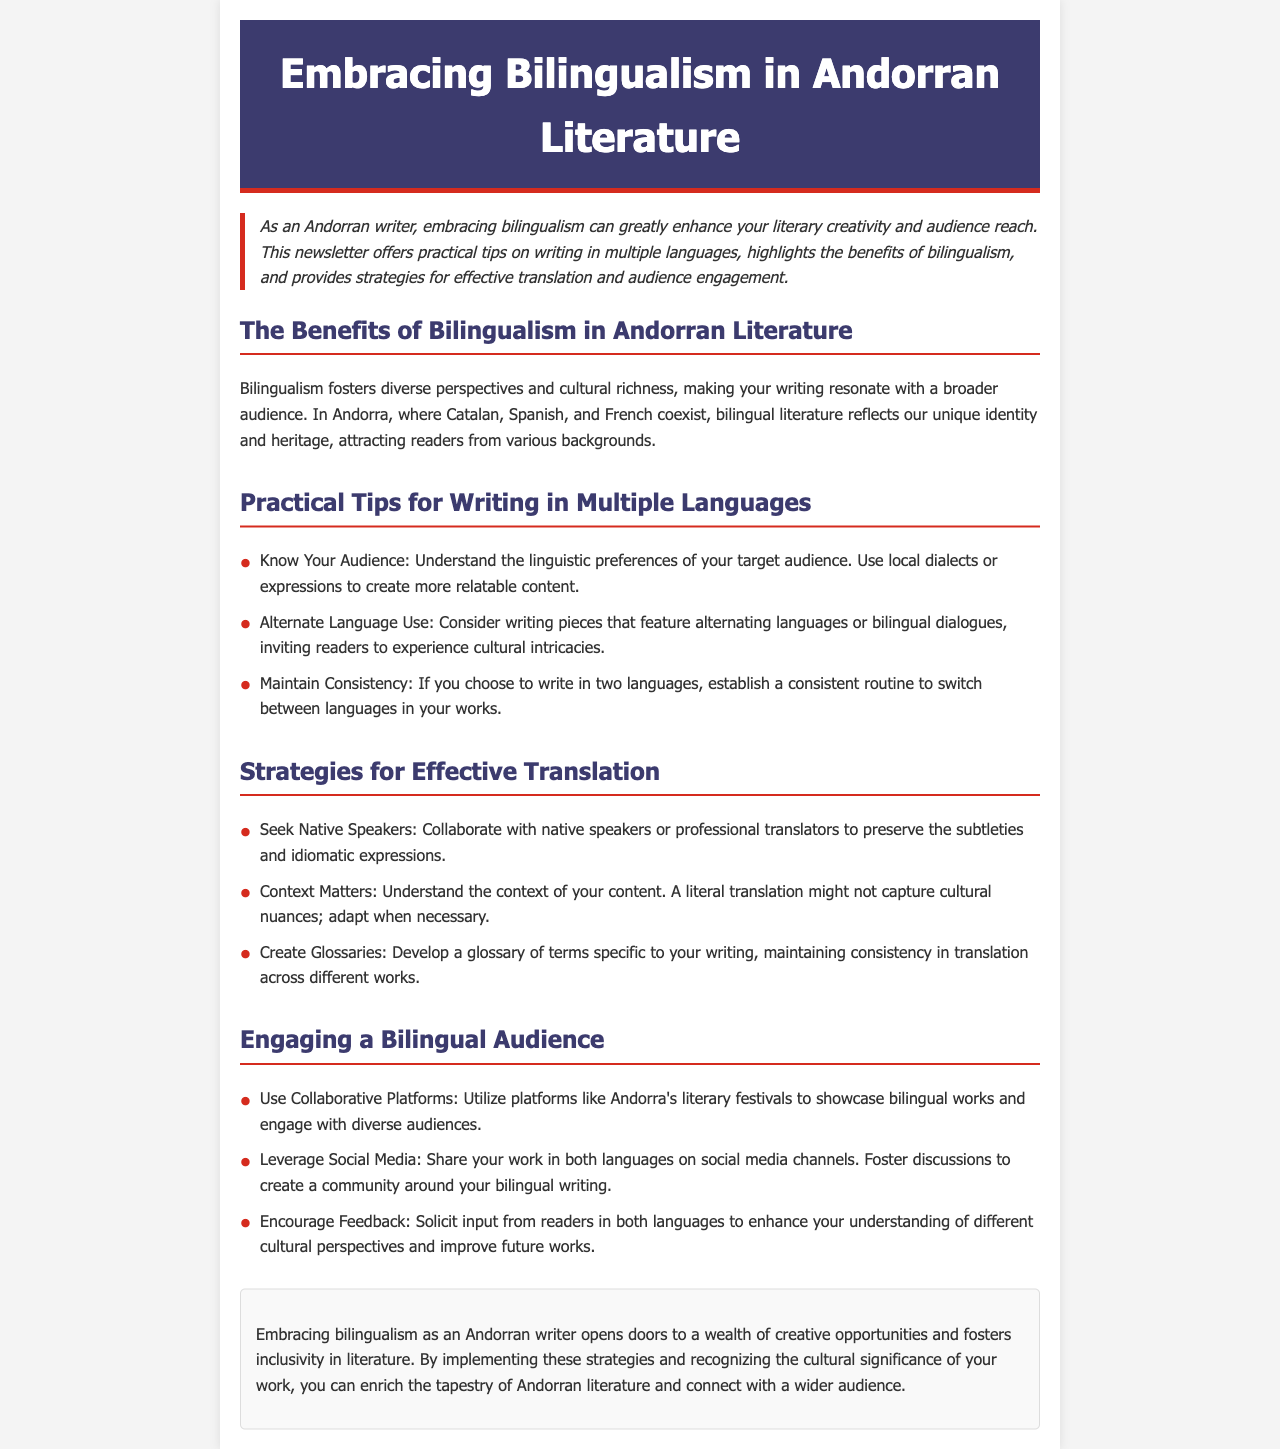What is the title of the newsletter? The title is mentioned prominently at the top of the document.
Answer: Embracing Bilingualism in Andorran Literature What is one benefit of bilingualism in Andorran literature? The document lists benefits in a specific section, highlighting cultural aspects.
Answer: Cultural richness Which three languages coexist in Andorra? The languages are referenced when discussing bilingual literature in Andorra.
Answer: Catalan, Spanish, and French What is a practical tip for writing in multiple languages? This tip is outlined in the practical writing section.
Answer: Know Your Audience What does the document suggest for effective translation? The document details strategies for translation in a specific section.
Answer: Seek Native Speakers What type of feedback should authors encourage from readers? The document specifies the type of input to enhance understanding.
Answer: Feedback in both languages What event does the document recommend for showcasing bilingual works? The recommendation is given in the section about audience engagement.
Answer: Andorra's literary festivals What is the last part of the newsletter called? The document labels the concluding section distinctly.
Answer: Conclusion 